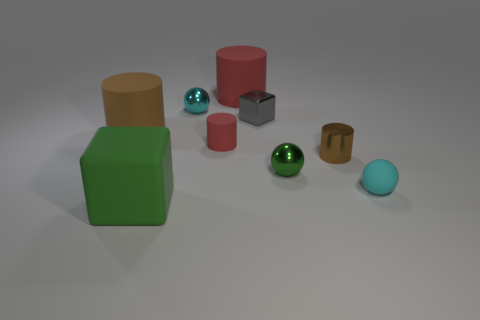Subtract all green cylinders. Subtract all yellow cubes. How many cylinders are left? 4 Subtract all blocks. How many objects are left? 7 Add 3 small metallic cubes. How many small metallic cubes are left? 4 Add 2 red metal cylinders. How many red metal cylinders exist? 2 Subtract 0 yellow cylinders. How many objects are left? 9 Subtract all gray metallic cubes. Subtract all green things. How many objects are left? 6 